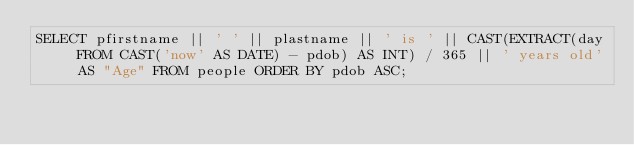Convert code to text. <code><loc_0><loc_0><loc_500><loc_500><_SQL_>SELECT pfirstname || ' ' || plastname || ' is ' || CAST(EXTRACT(day FROM CAST('now' AS DATE) - pdob) AS INT) / 365 || ' years old' AS "Age" FROM people ORDER BY pdob ASC;</code> 